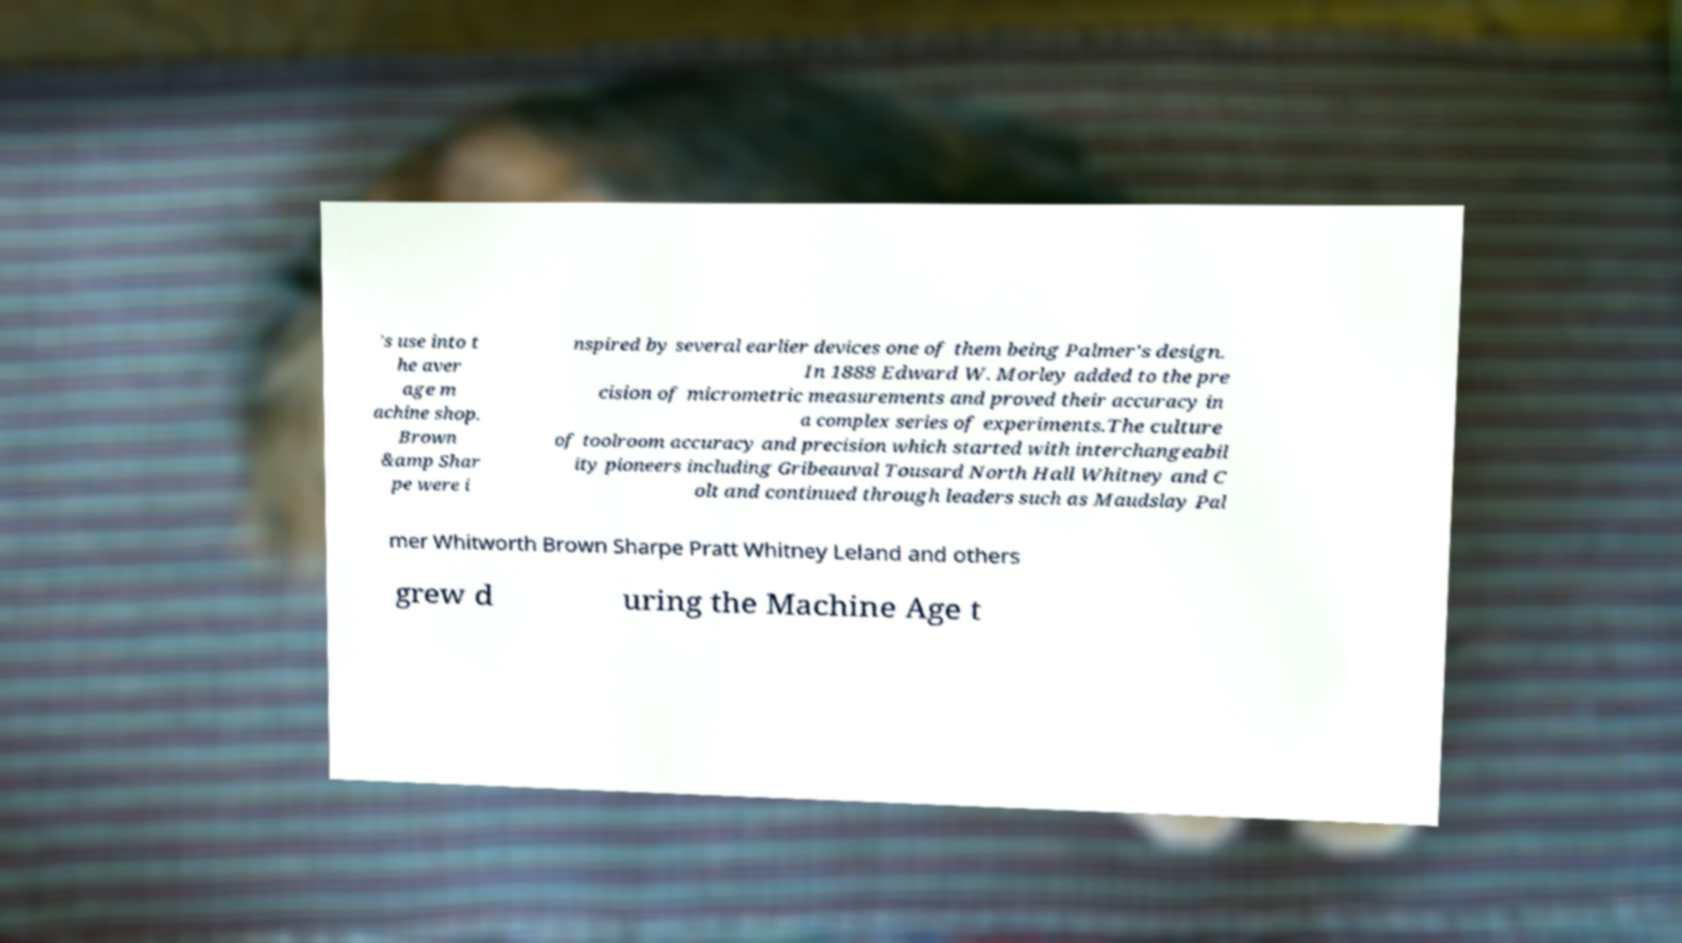Can you read and provide the text displayed in the image?This photo seems to have some interesting text. Can you extract and type it out for me? 's use into t he aver age m achine shop. Brown &amp Shar pe were i nspired by several earlier devices one of them being Palmer's design. In 1888 Edward W. Morley added to the pre cision of micrometric measurements and proved their accuracy in a complex series of experiments.The culture of toolroom accuracy and precision which started with interchangeabil ity pioneers including Gribeauval Tousard North Hall Whitney and C olt and continued through leaders such as Maudslay Pal mer Whitworth Brown Sharpe Pratt Whitney Leland and others grew d uring the Machine Age t 